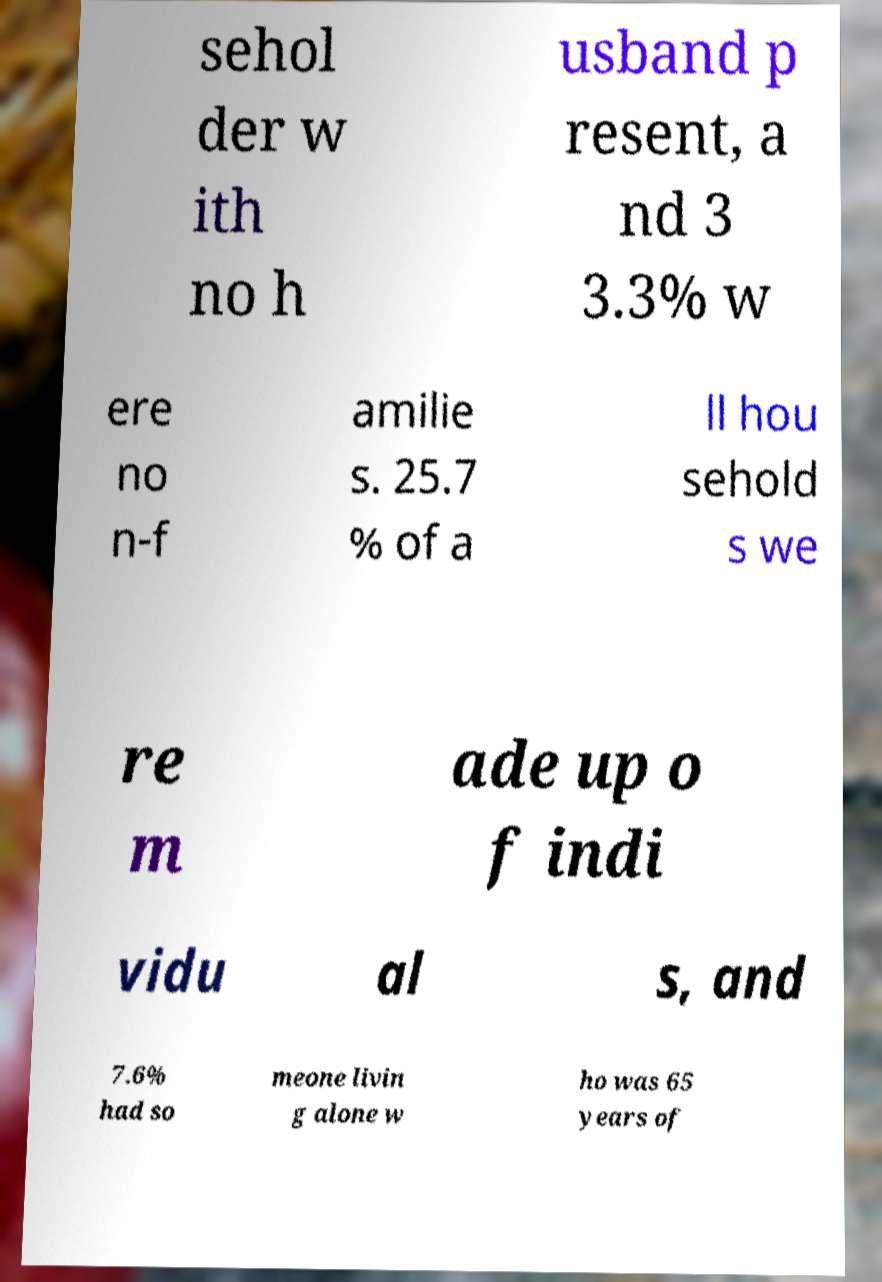Please identify and transcribe the text found in this image. sehol der w ith no h usband p resent, a nd 3 3.3% w ere no n-f amilie s. 25.7 % of a ll hou sehold s we re m ade up o f indi vidu al s, and 7.6% had so meone livin g alone w ho was 65 years of 